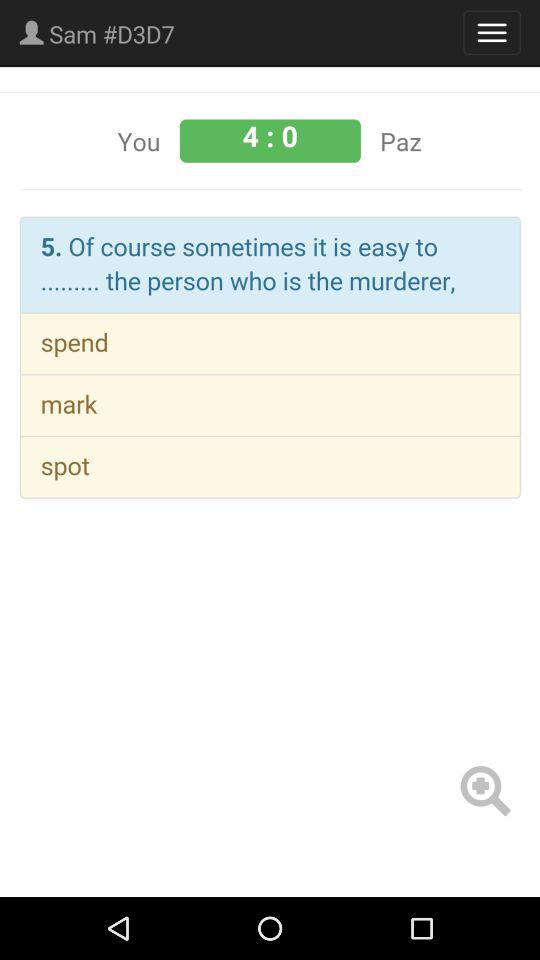What is the username? The username is "Sam #D3D7". 